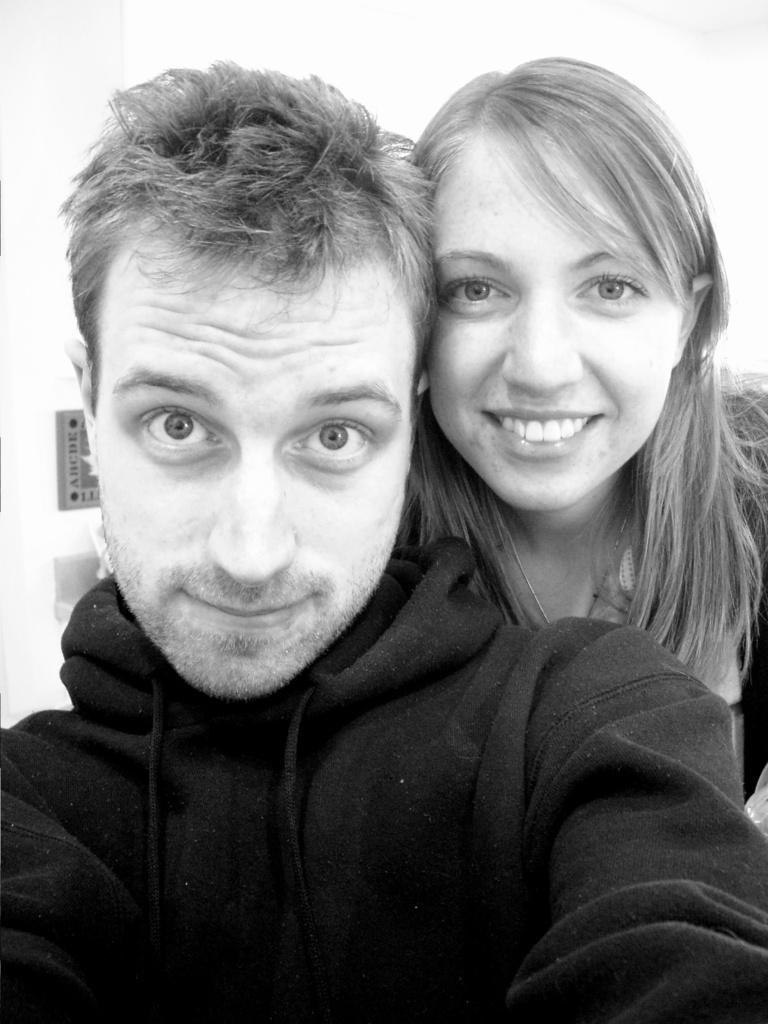Could you give a brief overview of what you see in this image? In this picture we can see a man and a woman, she is smiling and he wore a black color jacket. 